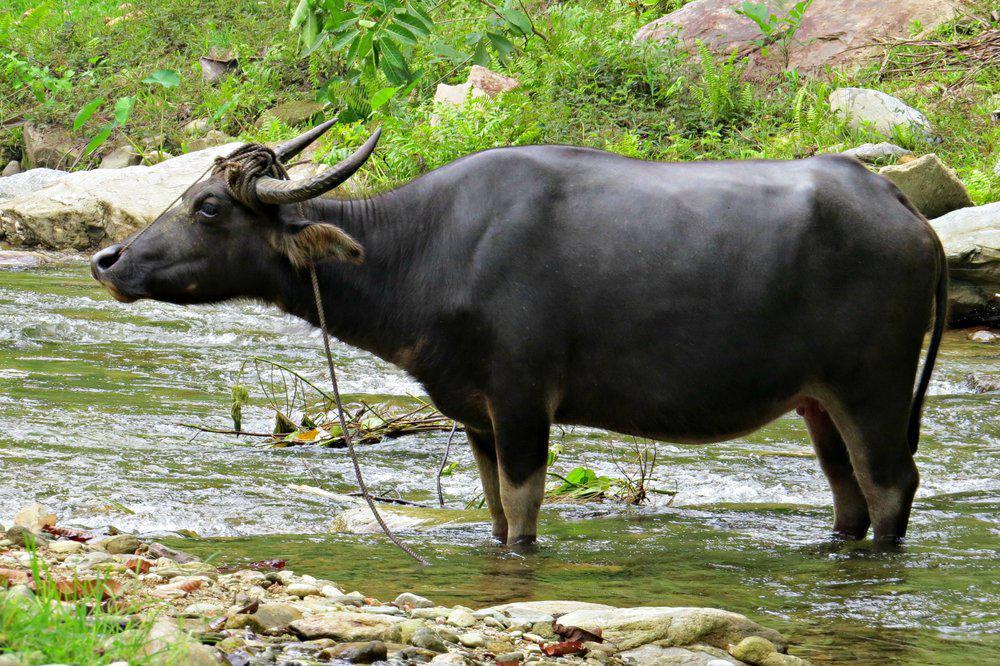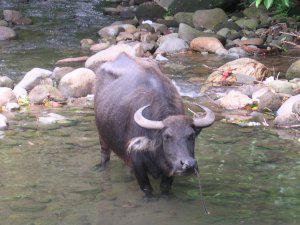The first image is the image on the left, the second image is the image on the right. Examine the images to the left and right. Is the description "Two animals are near a small body of water." accurate? Answer yes or no. Yes. The first image is the image on the left, the second image is the image on the right. Evaluate the accuracy of this statement regarding the images: "Each image contains exactly one dark water buffalo, and no images contain humans.". Is it true? Answer yes or no. Yes. 